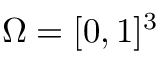Convert formula to latex. <formula><loc_0><loc_0><loc_500><loc_500>\Omega = [ 0 , 1 ] ^ { 3 }</formula> 